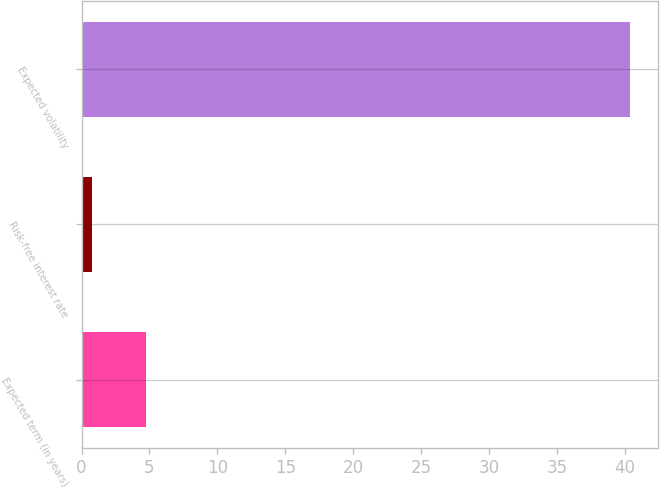<chart> <loc_0><loc_0><loc_500><loc_500><bar_chart><fcel>Expected term (in years)<fcel>Risk-free interest rate<fcel>Expected volatility<nl><fcel>4.76<fcel>0.8<fcel>40.4<nl></chart> 